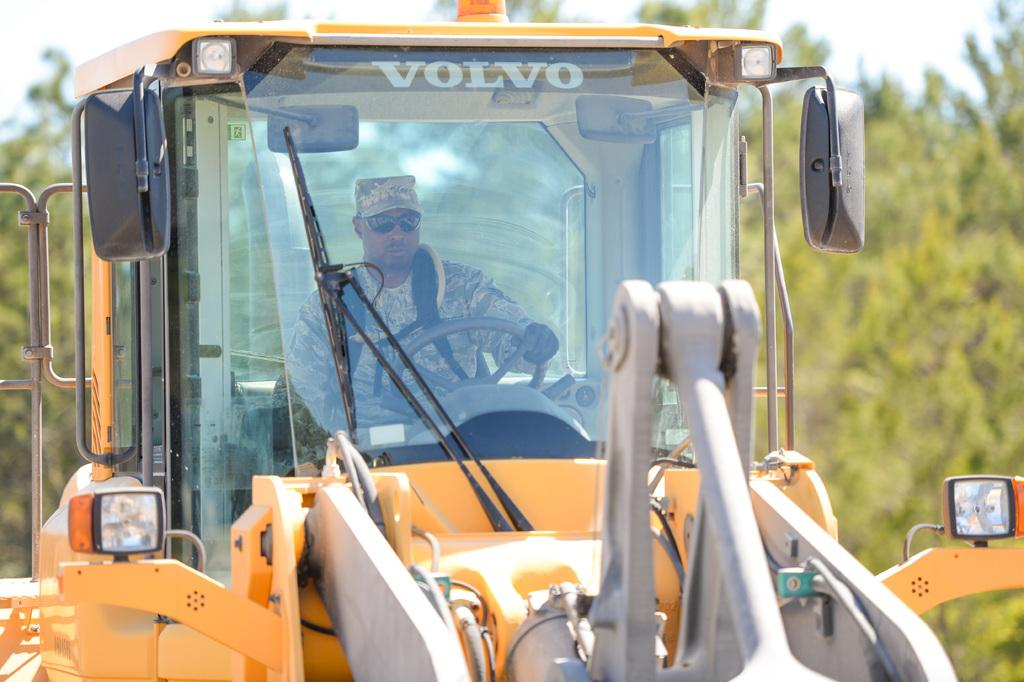What is the main subject of the image? There is a man in the image. What is the man doing in the image? The man is driving a yellow vehicle. What accessories is the man wearing in the image? The man has shades on his eyes and is wearing a cap. What can be seen in the background of the image? There are trees in the background of the image. What type of nerve can be seen in the image? There is no nerve present in the image. How many mice are visible in the image? There are no mice present in the image. 